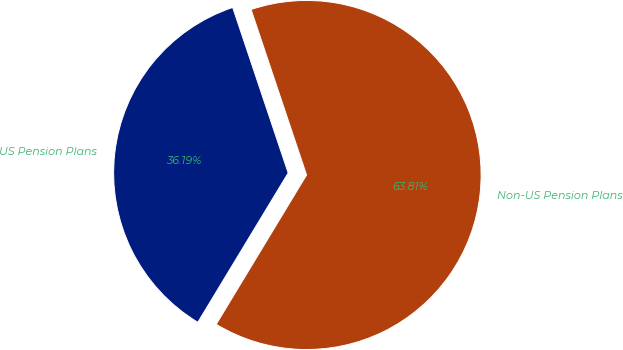Convert chart to OTSL. <chart><loc_0><loc_0><loc_500><loc_500><pie_chart><fcel>US Pension Plans<fcel>Non-US Pension Plans<nl><fcel>36.19%<fcel>63.81%<nl></chart> 